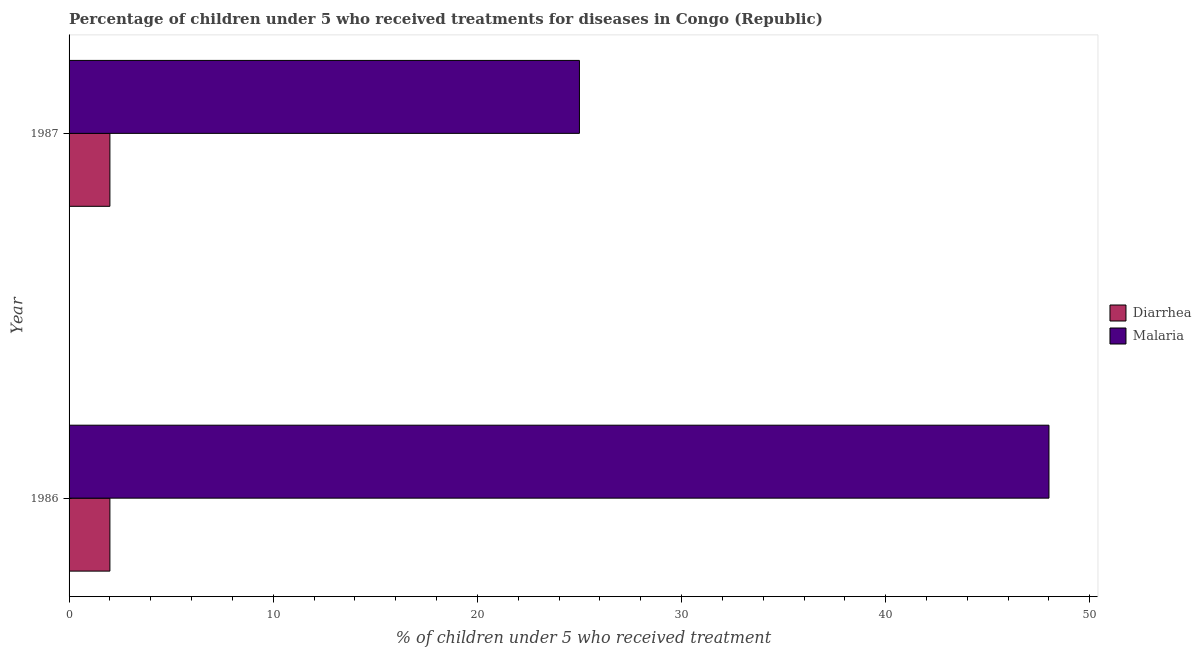Are the number of bars on each tick of the Y-axis equal?
Ensure brevity in your answer.  Yes. What is the label of the 1st group of bars from the top?
Provide a short and direct response. 1987. What is the percentage of children who received treatment for malaria in 1986?
Provide a succinct answer. 48. Across all years, what is the maximum percentage of children who received treatment for diarrhoea?
Your response must be concise. 2. Across all years, what is the minimum percentage of children who received treatment for diarrhoea?
Give a very brief answer. 2. In which year was the percentage of children who received treatment for malaria maximum?
Keep it short and to the point. 1986. What is the total percentage of children who received treatment for malaria in the graph?
Your response must be concise. 73. What is the difference between the percentage of children who received treatment for malaria in 1986 and that in 1987?
Make the answer very short. 23. What is the difference between the percentage of children who received treatment for malaria in 1987 and the percentage of children who received treatment for diarrhoea in 1986?
Ensure brevity in your answer.  23. What is the average percentage of children who received treatment for diarrhoea per year?
Offer a terse response. 2. In the year 1987, what is the difference between the percentage of children who received treatment for malaria and percentage of children who received treatment for diarrhoea?
Provide a short and direct response. 23. What is the ratio of the percentage of children who received treatment for diarrhoea in 1986 to that in 1987?
Offer a terse response. 1. Is the percentage of children who received treatment for diarrhoea in 1986 less than that in 1987?
Give a very brief answer. No. What does the 1st bar from the top in 1987 represents?
Offer a terse response. Malaria. What does the 1st bar from the bottom in 1987 represents?
Provide a short and direct response. Diarrhea. What is the difference between two consecutive major ticks on the X-axis?
Offer a very short reply. 10. Does the graph contain any zero values?
Provide a short and direct response. No. Does the graph contain grids?
Make the answer very short. No. How many legend labels are there?
Ensure brevity in your answer.  2. What is the title of the graph?
Offer a very short reply. Percentage of children under 5 who received treatments for diseases in Congo (Republic). Does "Highest 20% of population" appear as one of the legend labels in the graph?
Offer a terse response. No. What is the label or title of the X-axis?
Ensure brevity in your answer.  % of children under 5 who received treatment. What is the % of children under 5 who received treatment in Diarrhea in 1986?
Make the answer very short. 2. What is the % of children under 5 who received treatment in Diarrhea in 1987?
Ensure brevity in your answer.  2. What is the % of children under 5 who received treatment in Malaria in 1987?
Provide a succinct answer. 25. Across all years, what is the minimum % of children under 5 who received treatment of Diarrhea?
Keep it short and to the point. 2. Across all years, what is the minimum % of children under 5 who received treatment of Malaria?
Give a very brief answer. 25. What is the total % of children under 5 who received treatment of Diarrhea in the graph?
Your response must be concise. 4. What is the difference between the % of children under 5 who received treatment in Malaria in 1986 and that in 1987?
Ensure brevity in your answer.  23. What is the difference between the % of children under 5 who received treatment in Diarrhea in 1986 and the % of children under 5 who received treatment in Malaria in 1987?
Provide a short and direct response. -23. What is the average % of children under 5 who received treatment in Malaria per year?
Offer a very short reply. 36.5. In the year 1986, what is the difference between the % of children under 5 who received treatment in Diarrhea and % of children under 5 who received treatment in Malaria?
Give a very brief answer. -46. In the year 1987, what is the difference between the % of children under 5 who received treatment in Diarrhea and % of children under 5 who received treatment in Malaria?
Provide a succinct answer. -23. What is the ratio of the % of children under 5 who received treatment of Malaria in 1986 to that in 1987?
Provide a short and direct response. 1.92. What is the difference between the highest and the lowest % of children under 5 who received treatment of Malaria?
Provide a succinct answer. 23. 